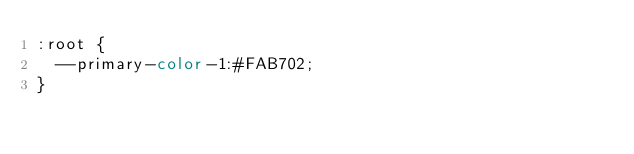<code> <loc_0><loc_0><loc_500><loc_500><_CSS_>:root {
  --primary-color-1:#FAB702;
}</code> 